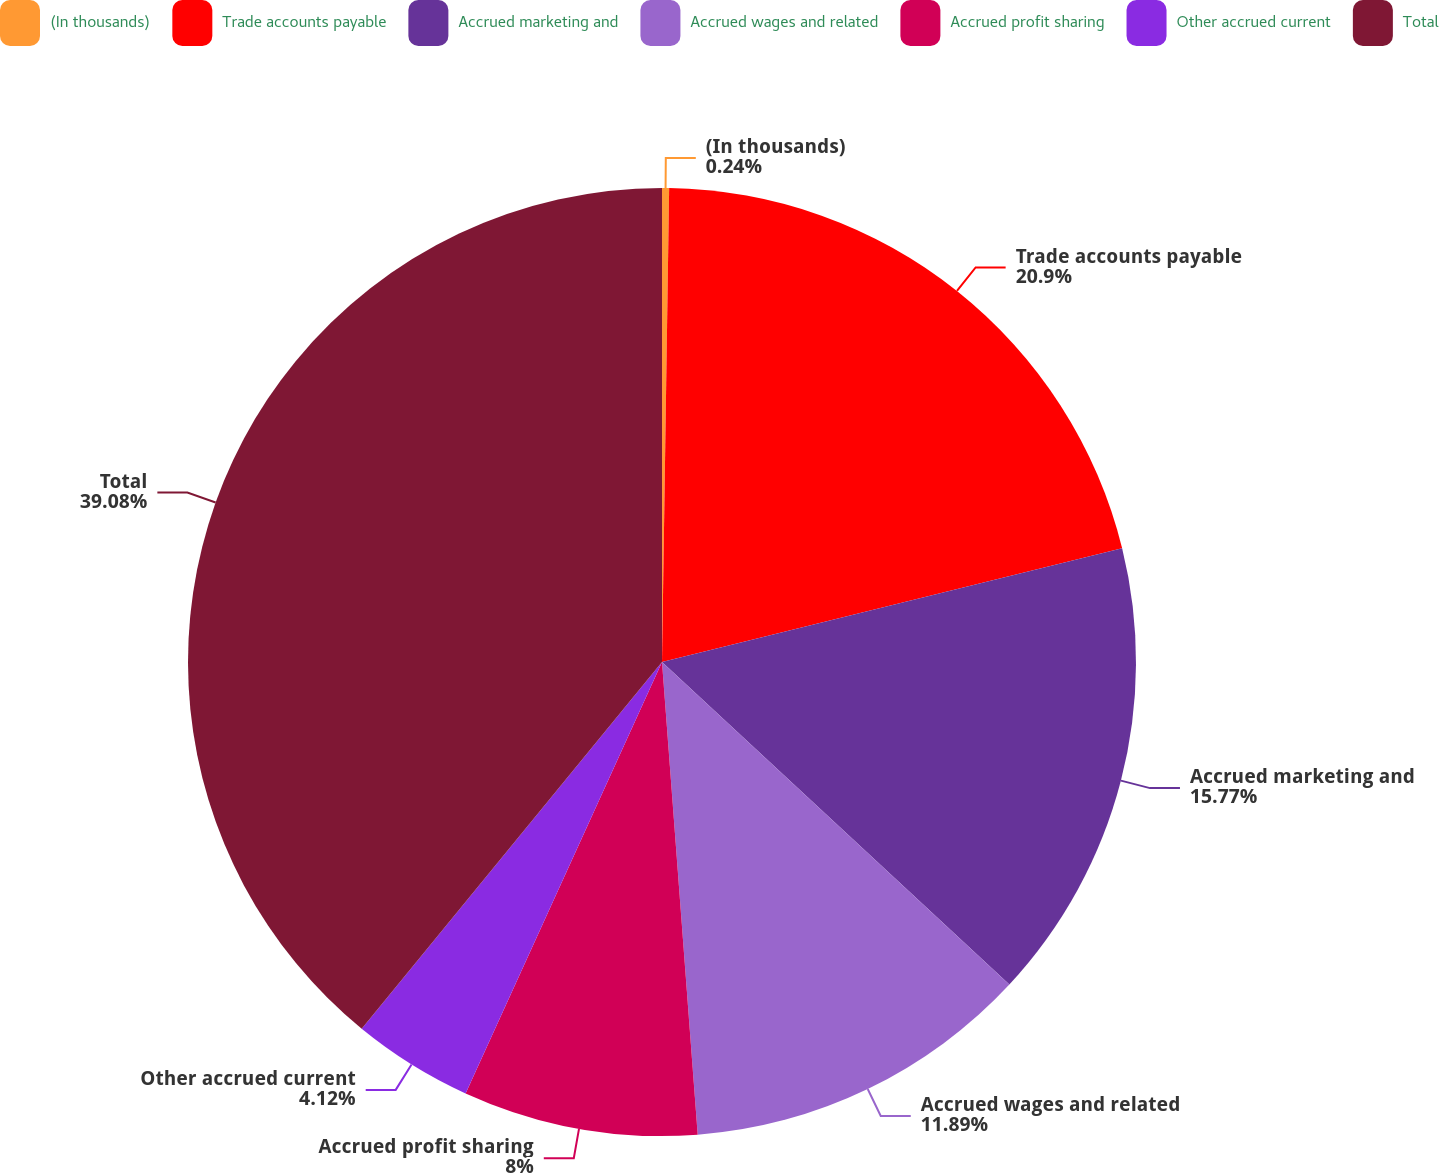Convert chart. <chart><loc_0><loc_0><loc_500><loc_500><pie_chart><fcel>(In thousands)<fcel>Trade accounts payable<fcel>Accrued marketing and<fcel>Accrued wages and related<fcel>Accrued profit sharing<fcel>Other accrued current<fcel>Total<nl><fcel>0.24%<fcel>20.9%<fcel>15.77%<fcel>11.89%<fcel>8.0%<fcel>4.12%<fcel>39.08%<nl></chart> 